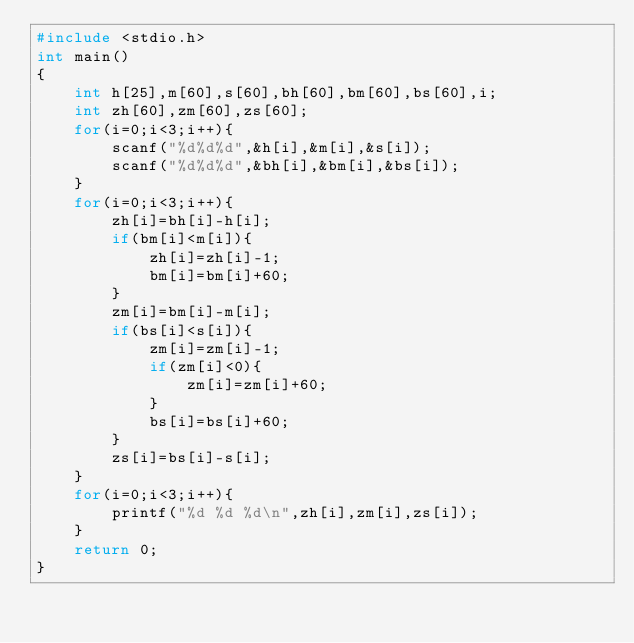Convert code to text. <code><loc_0><loc_0><loc_500><loc_500><_C_>#include <stdio.h>
int main()
{
	int h[25],m[60],s[60],bh[60],bm[60],bs[60],i;
	int zh[60],zm[60],zs[60];
	for(i=0;i<3;i++){
		scanf("%d%d%d",&h[i],&m[i],&s[i]);
		scanf("%d%d%d",&bh[i],&bm[i],&bs[i]);
	}
	for(i=0;i<3;i++){
		zh[i]=bh[i]-h[i];
		if(bm[i]<m[i]){
			zh[i]=zh[i]-1;
			bm[i]=bm[i]+60;
		}
		zm[i]=bm[i]-m[i];
		if(bs[i]<s[i]){
			zm[i]=zm[i]-1;
			if(zm[i]<0){
				zm[i]=zm[i]+60;
			}
			bs[i]=bs[i]+60;
		}
		zs[i]=bs[i]-s[i];
	}
	for(i=0;i<3;i++){
		printf("%d %d %d\n",zh[i],zm[i],zs[i]);
	}
	return 0;
}

</code> 